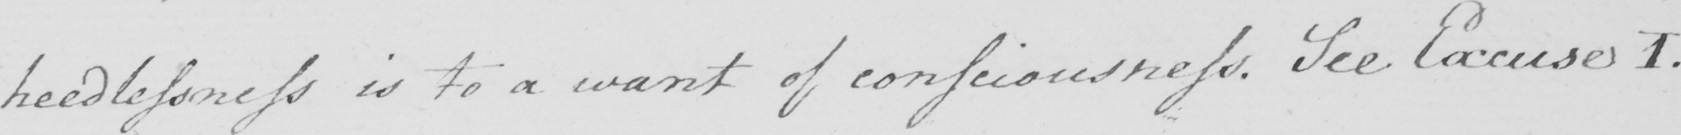Please transcribe the handwritten text in this image. heedlessness is to a want of consciousness . See Excuses 1 . 